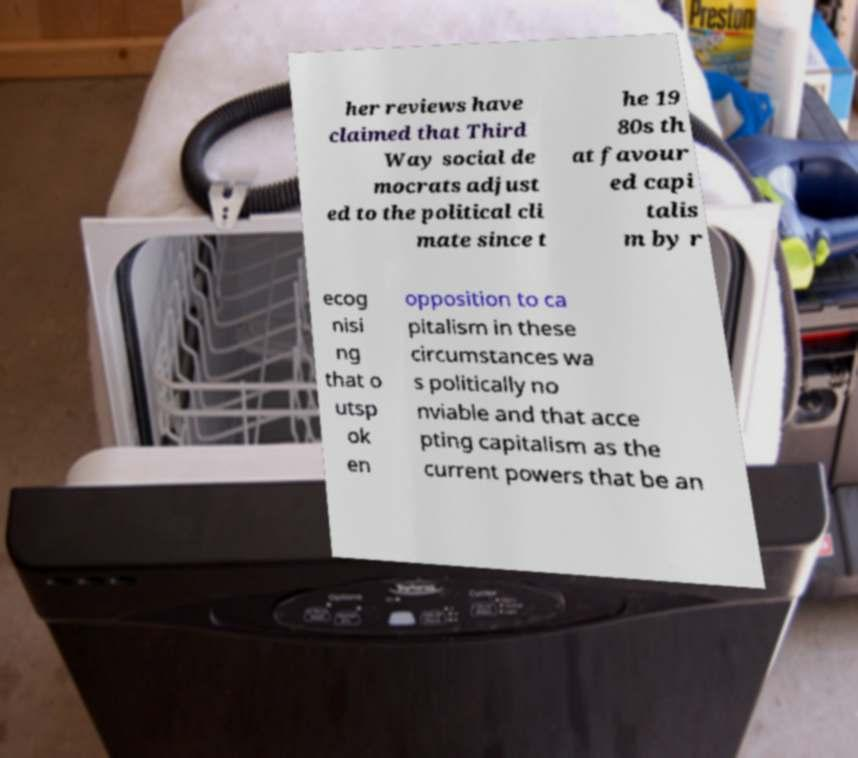Please read and relay the text visible in this image. What does it say? her reviews have claimed that Third Way social de mocrats adjust ed to the political cli mate since t he 19 80s th at favour ed capi talis m by r ecog nisi ng that o utsp ok en opposition to ca pitalism in these circumstances wa s politically no nviable and that acce pting capitalism as the current powers that be an 